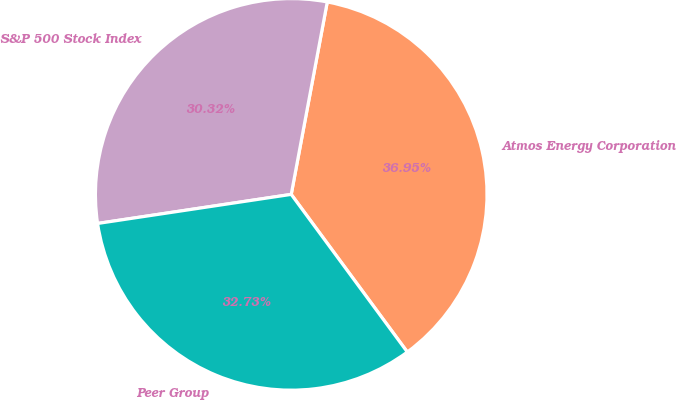Convert chart. <chart><loc_0><loc_0><loc_500><loc_500><pie_chart><fcel>Atmos Energy Corporation<fcel>S&P 500 Stock Index<fcel>Peer Group<nl><fcel>36.95%<fcel>30.32%<fcel>32.73%<nl></chart> 